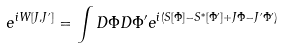<formula> <loc_0><loc_0><loc_500><loc_500>e ^ { i W [ J , J ^ { \prime } ] } = \int D \Phi D \Phi ^ { \prime } e ^ { i ( S [ \Phi ] - S ^ { * } [ \Phi ^ { \prime } ] + J \Phi - J ^ { \prime } \Phi ^ { \prime } ) }</formula> 